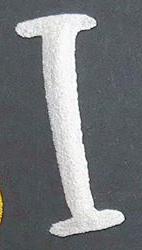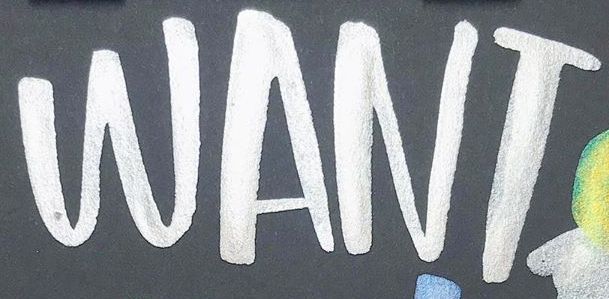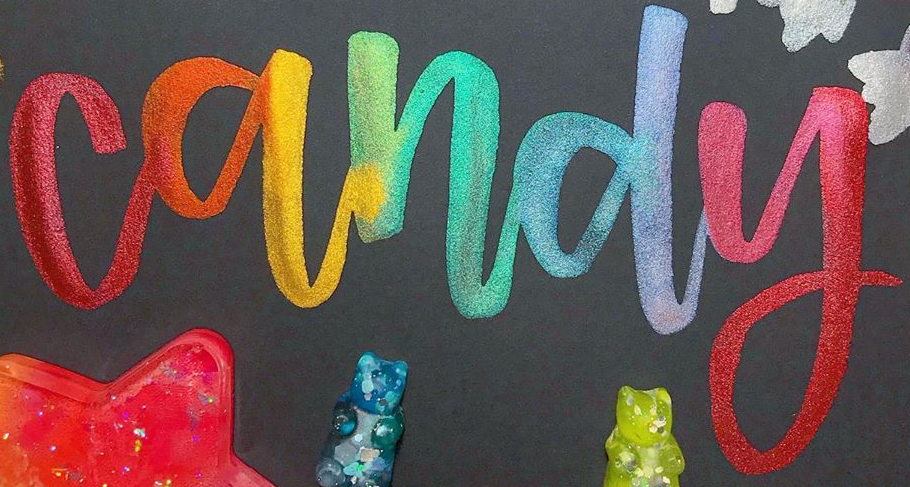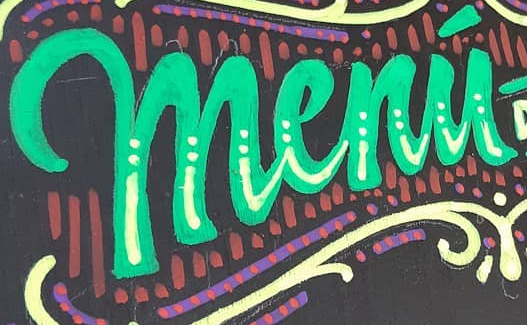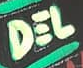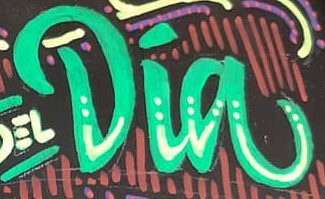What text is displayed in these images sequentially, separated by a semicolon? I; WANT; candy; menú; DEL; Dia 